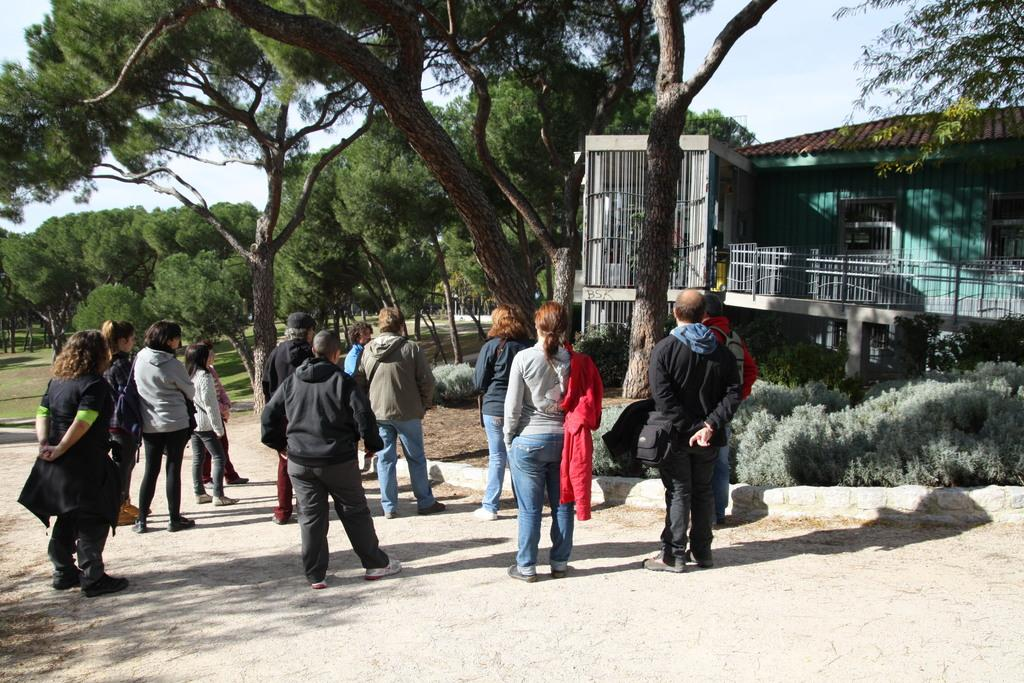What is the main subject of the image? The main subject of the image is a group of people standing in the middle of the image. What structure can be seen on the right side of the image? There is a house on the right side of the image. What type of vegetation is visible at the back of the image? There are trees visible at the back of the image. What is visible at the top of the image? The sky is visible at the top of the image. What type of hair can be seen on the government in the image? There is no government present in the image, and therefore no hair can be seen on it. 